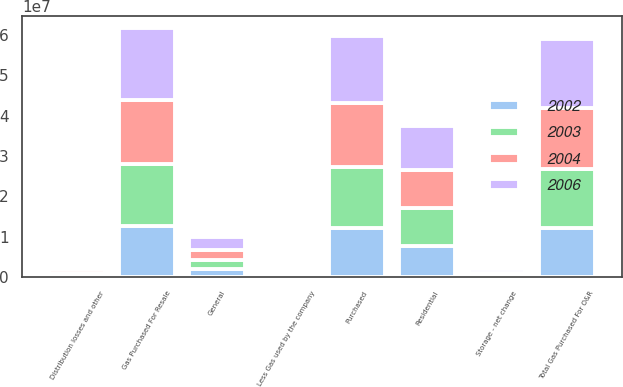<chart> <loc_0><loc_0><loc_500><loc_500><stacked_bar_chart><ecel><fcel>Purchased<fcel>Storage - net change<fcel>Gas Purchased For Resale<fcel>Less Gas used by the company<fcel>Distribution losses and other<fcel>Total Gas Purchased For O&R<fcel>Residential<fcel>General<nl><fcel>2002<fcel>1.2173e+07<fcel>409333<fcel>1.25824e+07<fcel>37630<fcel>294343<fcel>1.22504e+07<fcel>7.75844e+06<fcel>1.89156e+06<nl><fcel>2003<fcel>1.52083e+07<fcel>121547<fcel>1.53298e+07<fcel>48410<fcel>727243<fcel>1.45542e+07<fcel>9.30659e+06<fcel>2.26921e+06<nl><fcel>2004<fcel>1.57323e+07<fcel>373271<fcel>1.61056e+07<fcel>58823<fcel>1.01713e+06<fcel>1.50296e+07<fcel>9.48676e+06<fcel>2.4872e+06<nl><fcel>2006<fcel>1.65466e+07<fcel>1.11201e+06<fcel>1.76586e+07<fcel>52377<fcel>376605<fcel>1.72296e+07<fcel>1.08104e+07<fcel>3.31415e+06<nl></chart> 